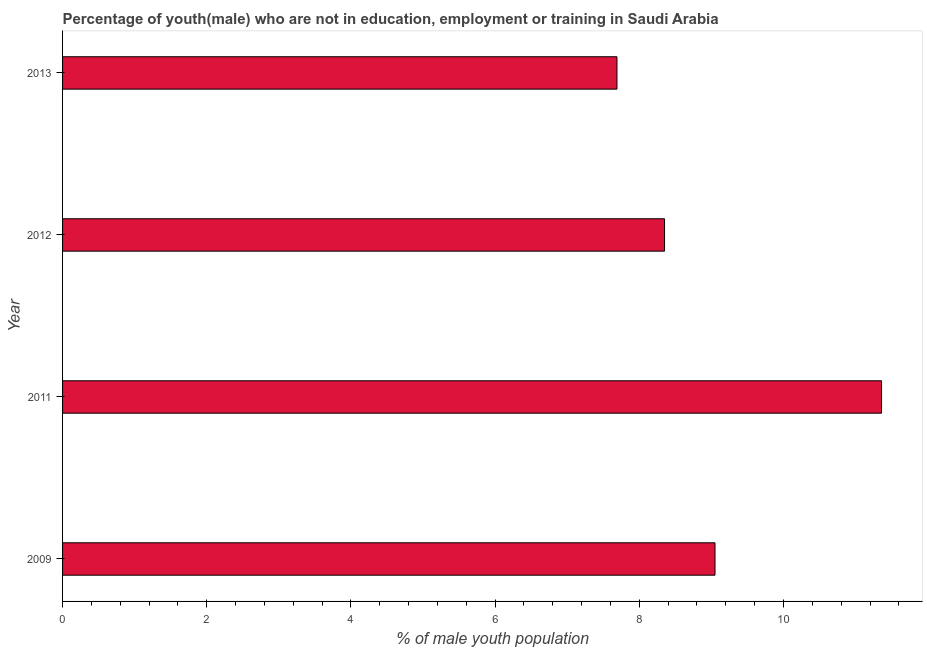Does the graph contain any zero values?
Your response must be concise. No. What is the title of the graph?
Offer a very short reply. Percentage of youth(male) who are not in education, employment or training in Saudi Arabia. What is the label or title of the X-axis?
Ensure brevity in your answer.  % of male youth population. What is the label or title of the Y-axis?
Your answer should be compact. Year. What is the unemployed male youth population in 2013?
Provide a short and direct response. 7.69. Across all years, what is the maximum unemployed male youth population?
Provide a succinct answer. 11.36. Across all years, what is the minimum unemployed male youth population?
Offer a terse response. 7.69. In which year was the unemployed male youth population maximum?
Offer a terse response. 2011. In which year was the unemployed male youth population minimum?
Ensure brevity in your answer.  2013. What is the sum of the unemployed male youth population?
Your response must be concise. 36.45. What is the difference between the unemployed male youth population in 2011 and 2013?
Give a very brief answer. 3.67. What is the average unemployed male youth population per year?
Offer a terse response. 9.11. What is the median unemployed male youth population?
Your answer should be compact. 8.7. What is the ratio of the unemployed male youth population in 2009 to that in 2013?
Provide a short and direct response. 1.18. What is the difference between the highest and the second highest unemployed male youth population?
Ensure brevity in your answer.  2.31. Is the sum of the unemployed male youth population in 2009 and 2011 greater than the maximum unemployed male youth population across all years?
Provide a short and direct response. Yes. What is the difference between the highest and the lowest unemployed male youth population?
Offer a terse response. 3.67. How many bars are there?
Make the answer very short. 4. What is the % of male youth population of 2009?
Your response must be concise. 9.05. What is the % of male youth population in 2011?
Keep it short and to the point. 11.36. What is the % of male youth population of 2012?
Your response must be concise. 8.35. What is the % of male youth population of 2013?
Keep it short and to the point. 7.69. What is the difference between the % of male youth population in 2009 and 2011?
Your answer should be very brief. -2.31. What is the difference between the % of male youth population in 2009 and 2012?
Make the answer very short. 0.7. What is the difference between the % of male youth population in 2009 and 2013?
Offer a very short reply. 1.36. What is the difference between the % of male youth population in 2011 and 2012?
Provide a succinct answer. 3.01. What is the difference between the % of male youth population in 2011 and 2013?
Keep it short and to the point. 3.67. What is the difference between the % of male youth population in 2012 and 2013?
Your answer should be very brief. 0.66. What is the ratio of the % of male youth population in 2009 to that in 2011?
Give a very brief answer. 0.8. What is the ratio of the % of male youth population in 2009 to that in 2012?
Your response must be concise. 1.08. What is the ratio of the % of male youth population in 2009 to that in 2013?
Provide a short and direct response. 1.18. What is the ratio of the % of male youth population in 2011 to that in 2012?
Ensure brevity in your answer.  1.36. What is the ratio of the % of male youth population in 2011 to that in 2013?
Offer a terse response. 1.48. What is the ratio of the % of male youth population in 2012 to that in 2013?
Your answer should be very brief. 1.09. 